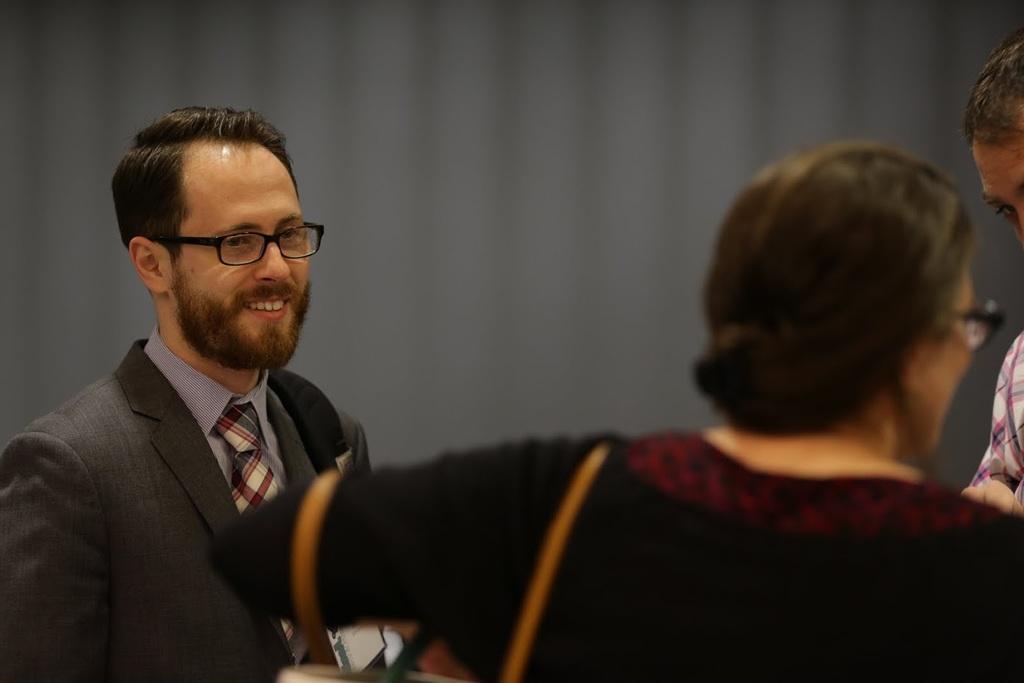In one or two sentences, can you explain what this image depicts? In the middle of the image few people are standing. Behind them there is a wall. 